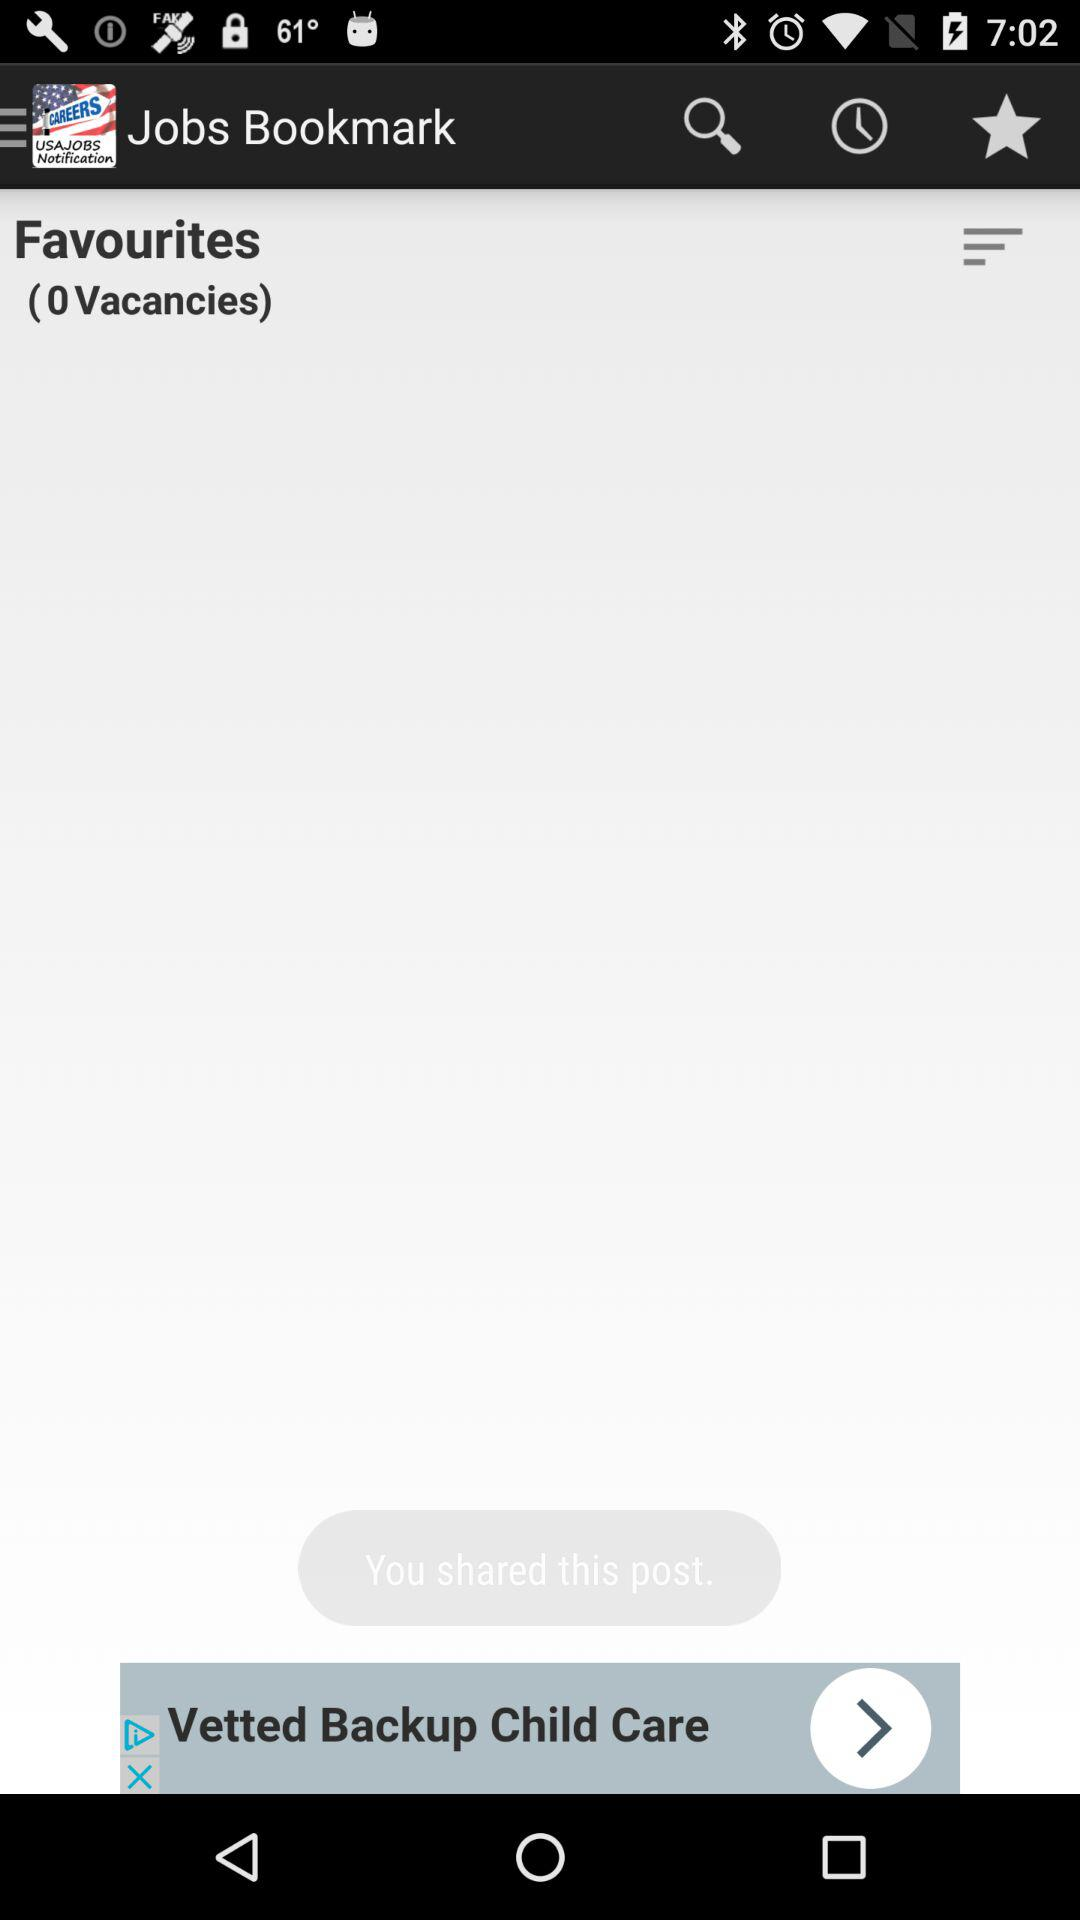How many vacancies are there? There are 0 vacancies. 